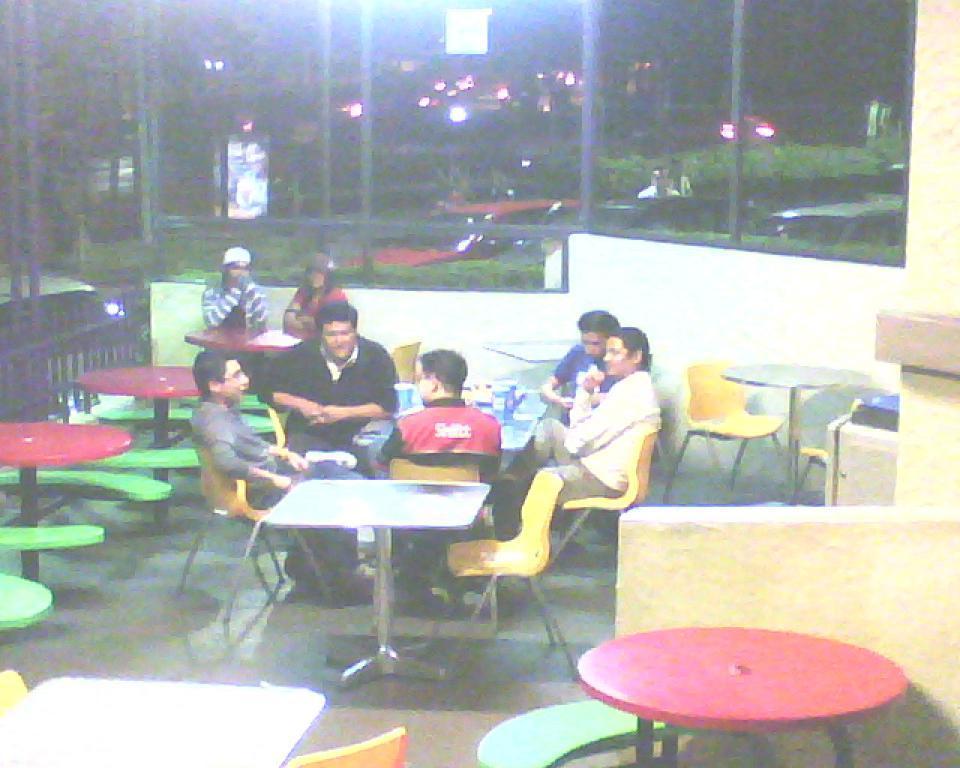Describe this image in one or two sentences. This picture shows a group of people seated on the chairs and we see few tables and trees and a light. 